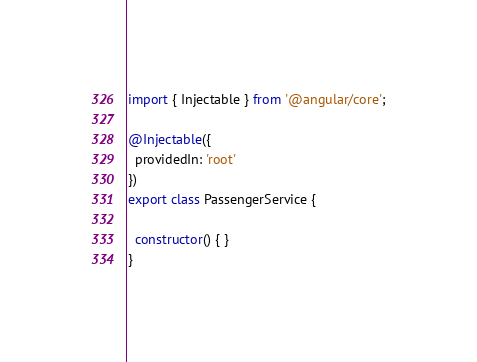Convert code to text. <code><loc_0><loc_0><loc_500><loc_500><_TypeScript_>import { Injectable } from '@angular/core';

@Injectable({
  providedIn: 'root'
})
export class PassengerService {

  constructor() { }
}
</code> 